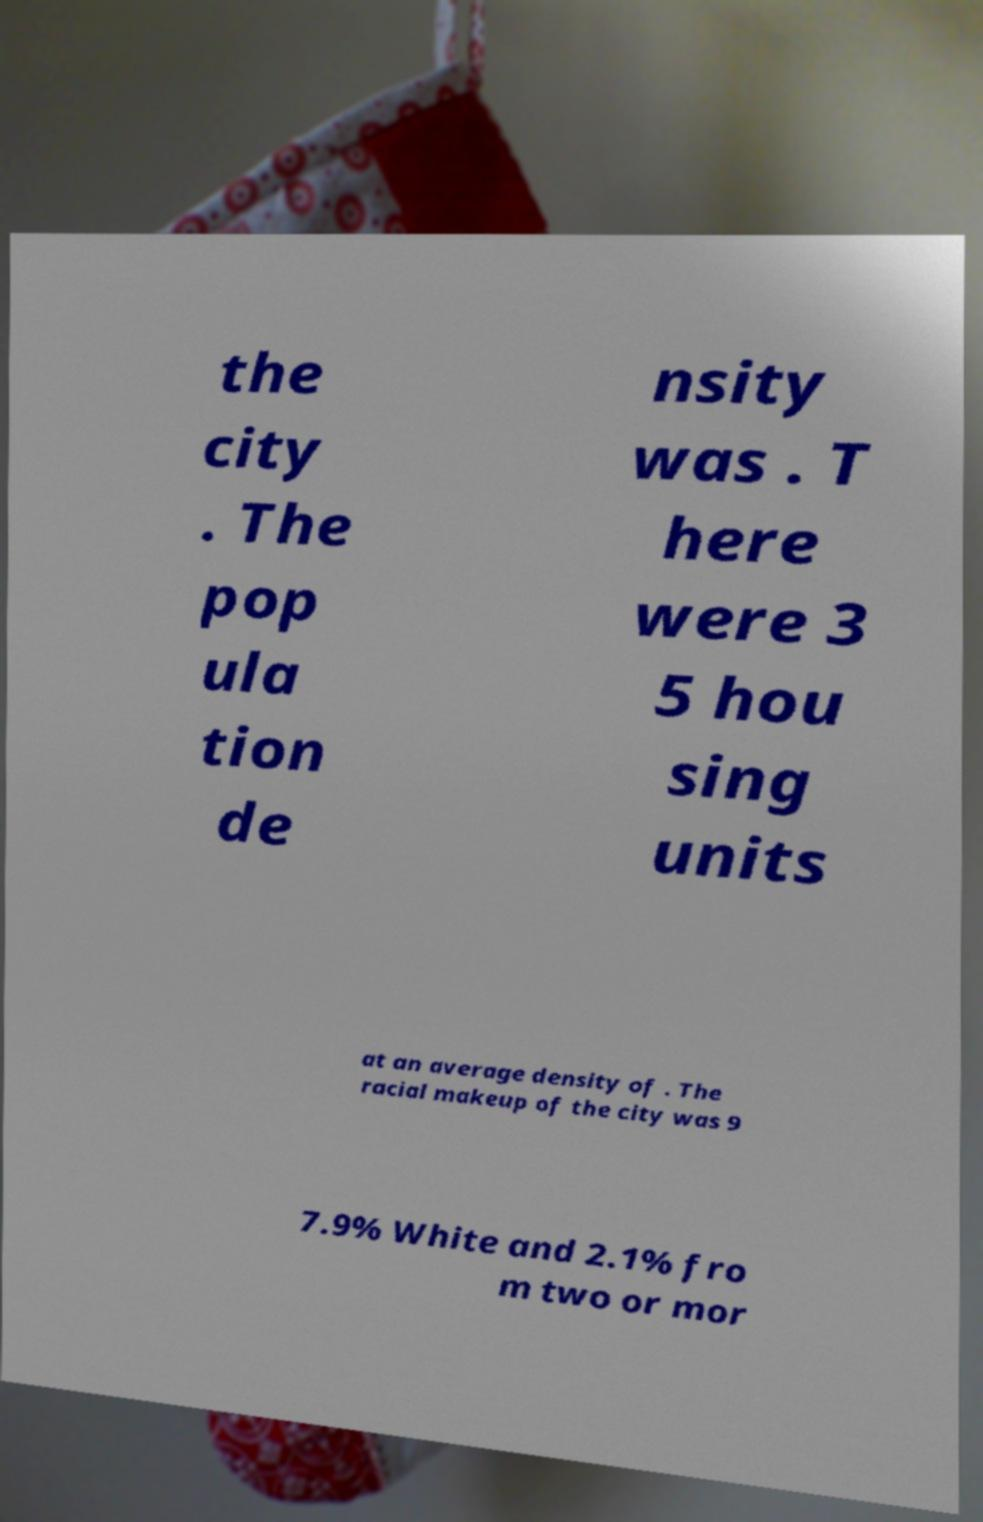Can you accurately transcribe the text from the provided image for me? the city . The pop ula tion de nsity was . T here were 3 5 hou sing units at an average density of . The racial makeup of the city was 9 7.9% White and 2.1% fro m two or mor 